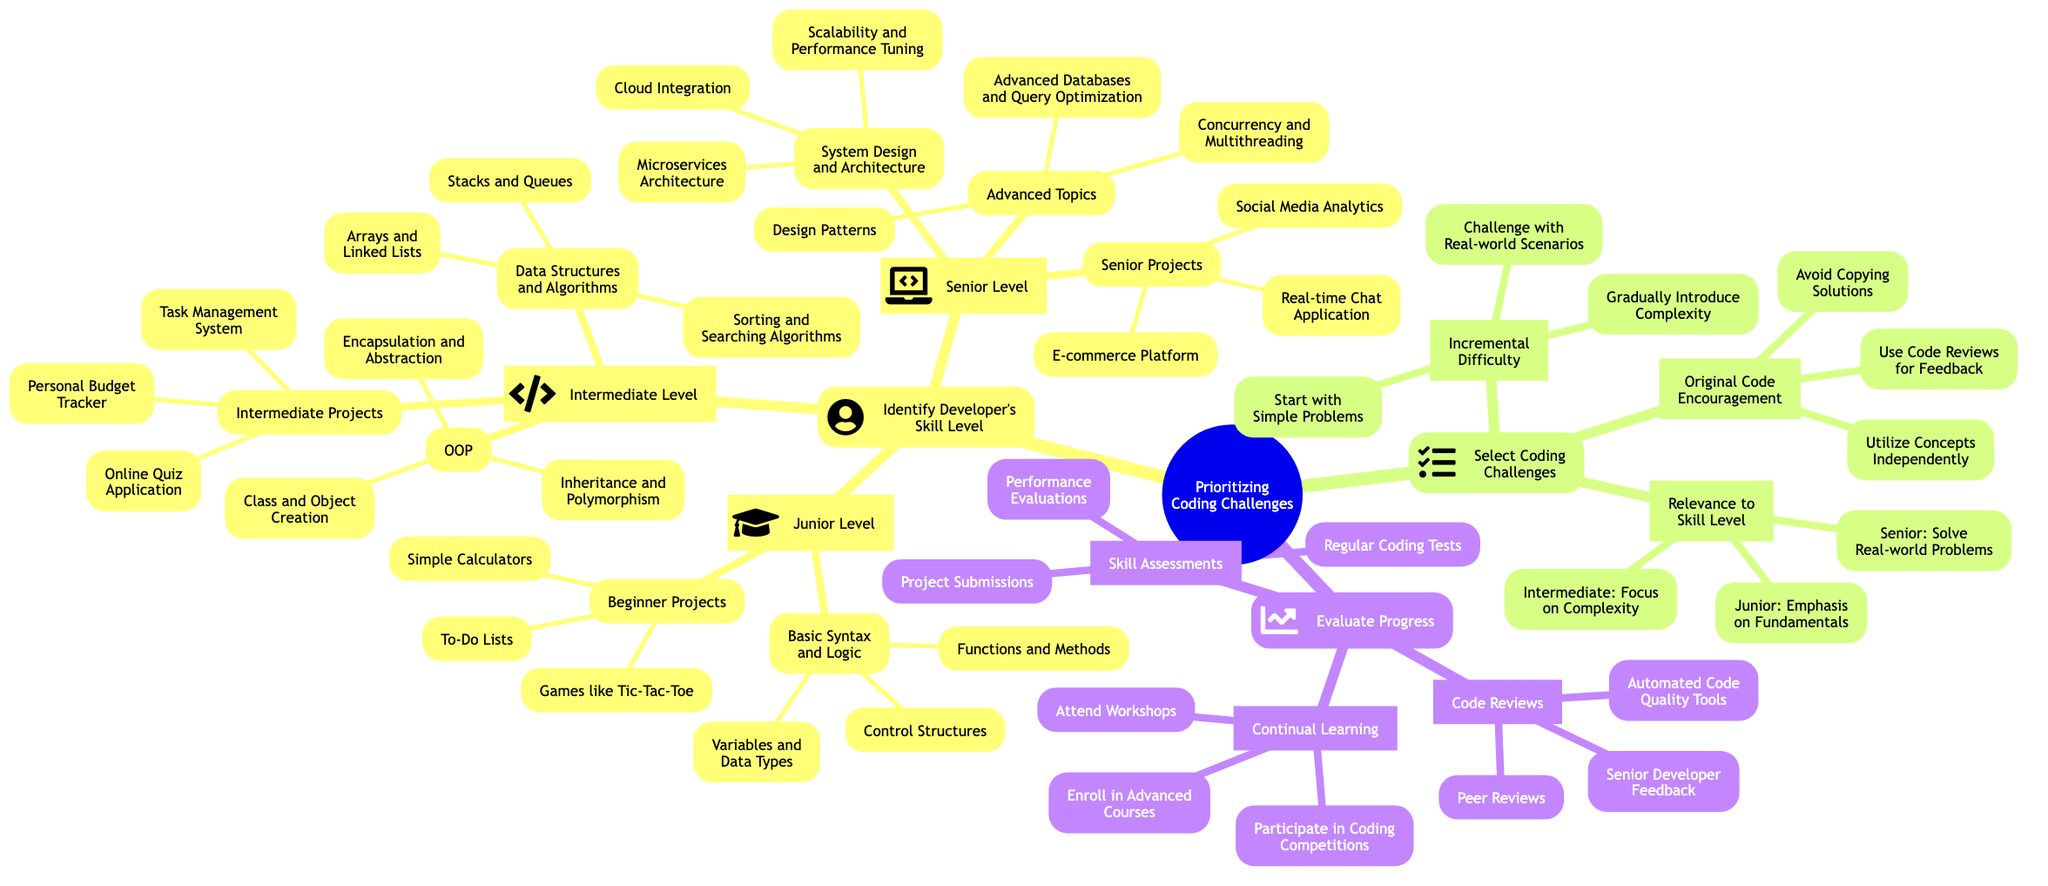What is the highest skill level identified in the diagram? The diagram shows three skill levels: Junior, Intermediate, and Senior. Among these, Senior is the highest level indicated as it represents the most advanced stage of skill development in coding.
Answer: Senior How many types of projects are listed under Junior Level? In the Junior Level section, there are two categories of projects: Beginner Projects and Basic Syntax and Logic. Under Beginner Projects, there are three specific projects mentioned. Counting these gives a total of three projects.
Answer: Three What is the focus of coding challenges for Intermediate Level? The diagram indicates that the focus for Intermediate Level coding challenges is on Complexity. This is stated directly under the Select Coding Challenges section for Intermediate Level.
Answer: Complexity Which topic is associated with Advanced Topics for the Senior Level? Under the Senior Level section, Advanced Topics includes topics like Design Patterns, Concurrency and Multithreading, and Advanced Databases and Query Optimization. This directly indicates that these topics are specifically outlined in the diagram.
Answer: Design Patterns What are the three aspects of evaluating progress in coding skills? The Evaluate Progress section identifies three components: Code Reviews, Skill Assessments, and Continual Learning. Each of these components play a critical role in monitoring and improving coding skills.
Answer: Code Reviews, Skill Assessments, Continual Learning What is one key principle for Original Code Encouragement? Among the key principles for Original Code Encouragement, one stated clearly is to "Avoid Copying Solutions." This demonstrates the importance placed on originality and independent problem solving.
Answer: Avoid Copying Solutions How many categories are present under the Senior Level? The Senior Level section is divided into three categories: Advanced Topics, System Design and Architecture, and Senior Projects. Therefore, there are three distinct categories under the Senior Level.
Answer: Three Which coding challenge type encourages starting with simple problems? The Incremental Difficulty section explicitly states to "Start with Simple Problems" as part of its encouragement, underscoring the progression that should occur in skill development.
Answer: Start with Simple Problems What role do Peer Reviews play in evaluating progress? Peer Reviews are one specific type of Code Reviews mentioned in the Evaluate Progress section of the diagram. They serve as a method for gathering feedback from fellow developers on coding challenges and projects.
Answer: Peer Reviews 